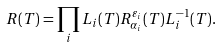Convert formula to latex. <formula><loc_0><loc_0><loc_500><loc_500>R ( T ) = \prod _ { i } L _ { i } ( T ) R ^ { \varepsilon _ { i } } _ { \alpha _ { i } } ( T ) L ^ { - 1 } _ { i } ( T ) .</formula> 